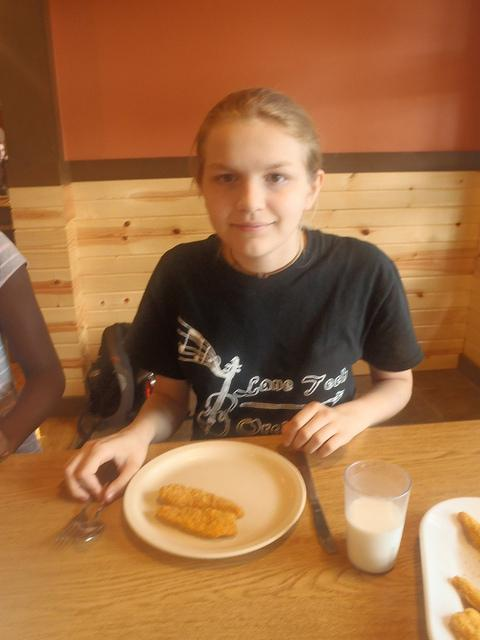What side dish would compliment his food quite well? Please explain your reasoning. fries. The side dish is fries. 